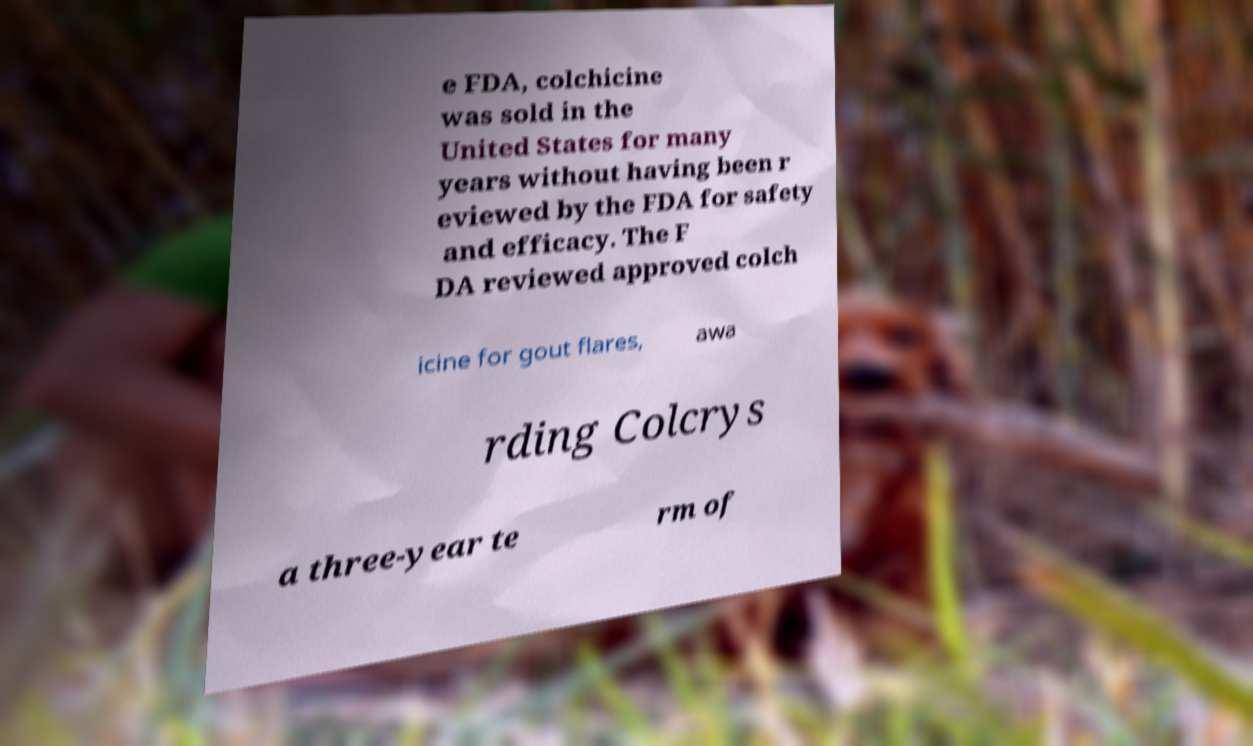Can you accurately transcribe the text from the provided image for me? e FDA, colchicine was sold in the United States for many years without having been r eviewed by the FDA for safety and efficacy. The F DA reviewed approved colch icine for gout flares, awa rding Colcrys a three-year te rm of 